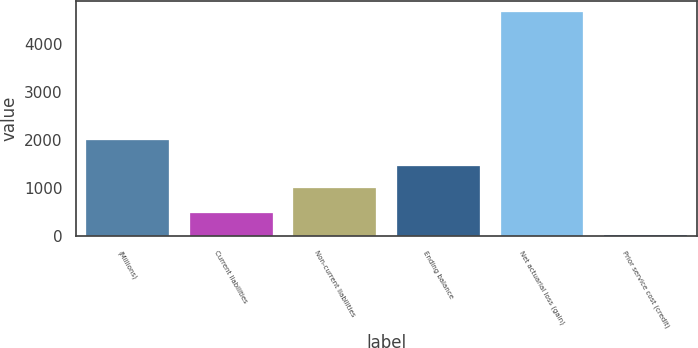Convert chart to OTSL. <chart><loc_0><loc_0><loc_500><loc_500><bar_chart><fcel>(Millions)<fcel>Current liabilities<fcel>Non-current liabilities<fcel>Ending balance<fcel>Net actuarial loss (gain)<fcel>Prior service cost (credit)<nl><fcel>2012<fcel>489.5<fcel>1006<fcel>1471.5<fcel>4679<fcel>24<nl></chart> 